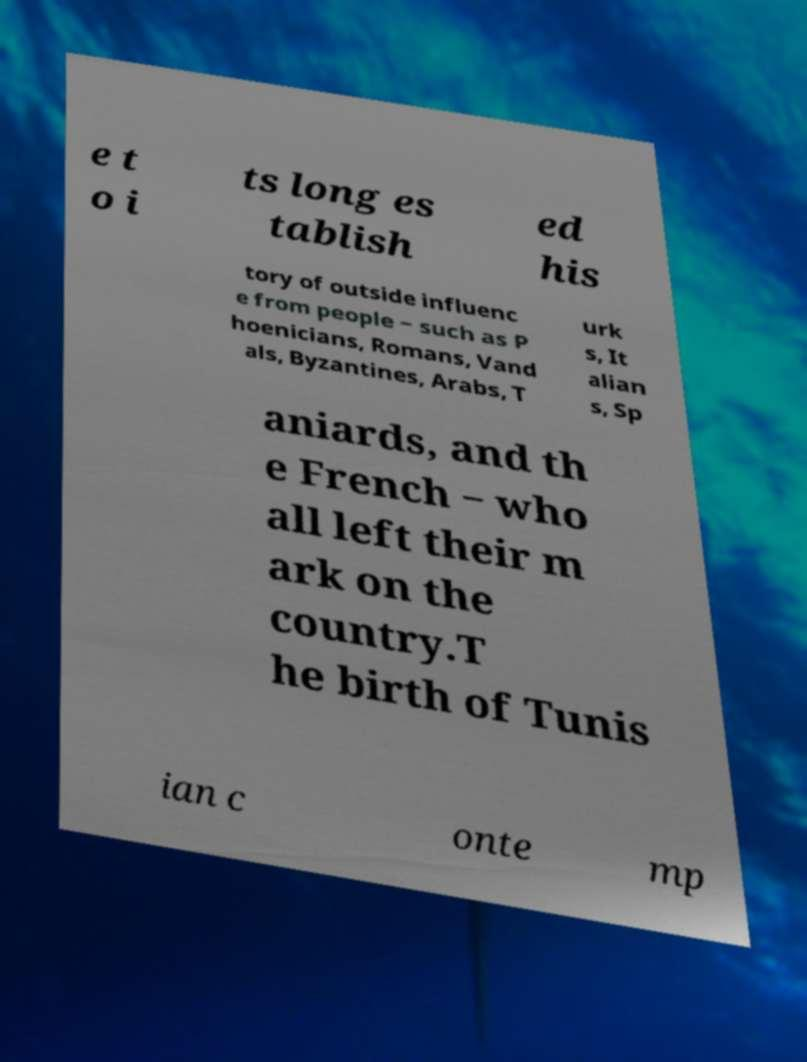Please identify and transcribe the text found in this image. e t o i ts long es tablish ed his tory of outside influenc e from people ‒ such as P hoenicians, Romans, Vand als, Byzantines, Arabs, T urk s, It alian s, Sp aniards, and th e French ‒ who all left their m ark on the country.T he birth of Tunis ian c onte mp 